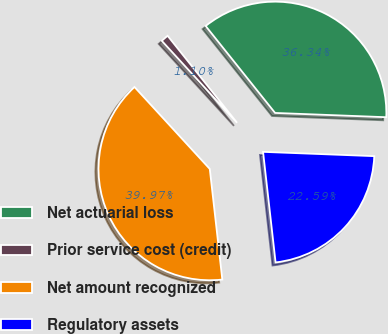<chart> <loc_0><loc_0><loc_500><loc_500><pie_chart><fcel>Net actuarial loss<fcel>Prior service cost (credit)<fcel>Net amount recognized<fcel>Regulatory assets<nl><fcel>36.34%<fcel>1.1%<fcel>39.97%<fcel>22.59%<nl></chart> 